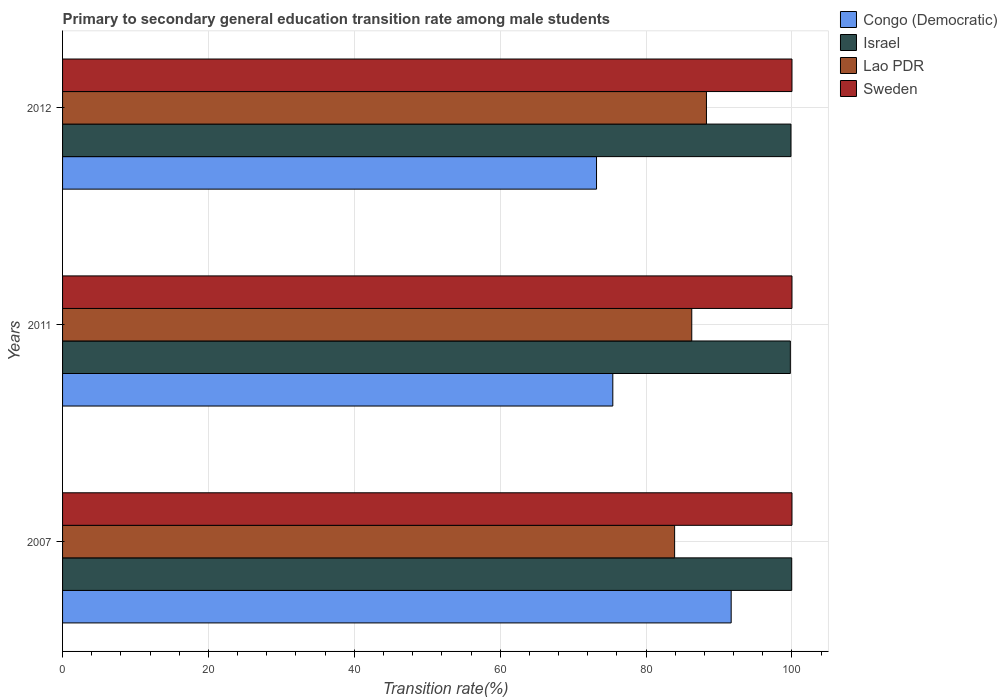How many different coloured bars are there?
Keep it short and to the point. 4. How many groups of bars are there?
Offer a very short reply. 3. Are the number of bars per tick equal to the number of legend labels?
Your response must be concise. Yes. Are the number of bars on each tick of the Y-axis equal?
Give a very brief answer. Yes. What is the label of the 1st group of bars from the top?
Your answer should be very brief. 2012. What is the transition rate in Lao PDR in 2012?
Your answer should be very brief. 88.27. Across all years, what is the maximum transition rate in Israel?
Keep it short and to the point. 99.96. Across all years, what is the minimum transition rate in Sweden?
Your answer should be very brief. 100. In which year was the transition rate in Israel maximum?
Give a very brief answer. 2007. What is the total transition rate in Lao PDR in the graph?
Make the answer very short. 258.44. What is the difference between the transition rate in Israel in 2007 and that in 2011?
Your answer should be compact. 0.19. What is the difference between the transition rate in Israel in 2011 and the transition rate in Congo (Democratic) in 2012?
Your answer should be very brief. 26.57. What is the average transition rate in Lao PDR per year?
Make the answer very short. 86.15. In the year 2007, what is the difference between the transition rate in Lao PDR and transition rate in Sweden?
Offer a terse response. -16.09. What is the ratio of the transition rate in Congo (Democratic) in 2007 to that in 2011?
Provide a succinct answer. 1.22. Is the transition rate in Lao PDR in 2007 less than that in 2012?
Your answer should be compact. Yes. Is the difference between the transition rate in Lao PDR in 2007 and 2011 greater than the difference between the transition rate in Sweden in 2007 and 2011?
Make the answer very short. No. What is the difference between the highest and the second highest transition rate in Israel?
Your answer should be very brief. 0.1. What is the difference between the highest and the lowest transition rate in Israel?
Offer a terse response. 0.19. In how many years, is the transition rate in Israel greater than the average transition rate in Israel taken over all years?
Your response must be concise. 1. Is the sum of the transition rate in Sweden in 2007 and 2012 greater than the maximum transition rate in Congo (Democratic) across all years?
Offer a terse response. Yes. What does the 1st bar from the bottom in 2011 represents?
Offer a terse response. Congo (Democratic). How many bars are there?
Offer a terse response. 12. Are all the bars in the graph horizontal?
Ensure brevity in your answer.  Yes. What is the difference between two consecutive major ticks on the X-axis?
Your answer should be compact. 20. How many legend labels are there?
Your answer should be very brief. 4. What is the title of the graph?
Offer a terse response. Primary to secondary general education transition rate among male students. What is the label or title of the X-axis?
Give a very brief answer. Transition rate(%). What is the label or title of the Y-axis?
Offer a very short reply. Years. What is the Transition rate(%) in Congo (Democratic) in 2007?
Your answer should be compact. 91.66. What is the Transition rate(%) of Israel in 2007?
Provide a succinct answer. 99.96. What is the Transition rate(%) in Lao PDR in 2007?
Offer a terse response. 83.91. What is the Transition rate(%) of Sweden in 2007?
Ensure brevity in your answer.  100. What is the Transition rate(%) of Congo (Democratic) in 2011?
Provide a short and direct response. 75.44. What is the Transition rate(%) of Israel in 2011?
Make the answer very short. 99.78. What is the Transition rate(%) of Lao PDR in 2011?
Your answer should be very brief. 86.26. What is the Transition rate(%) of Sweden in 2011?
Provide a short and direct response. 100. What is the Transition rate(%) of Congo (Democratic) in 2012?
Keep it short and to the point. 73.2. What is the Transition rate(%) in Israel in 2012?
Your answer should be compact. 99.86. What is the Transition rate(%) of Lao PDR in 2012?
Ensure brevity in your answer.  88.27. What is the Transition rate(%) in Sweden in 2012?
Keep it short and to the point. 100. Across all years, what is the maximum Transition rate(%) of Congo (Democratic)?
Your answer should be compact. 91.66. Across all years, what is the maximum Transition rate(%) in Israel?
Offer a terse response. 99.96. Across all years, what is the maximum Transition rate(%) in Lao PDR?
Your response must be concise. 88.27. Across all years, what is the minimum Transition rate(%) of Congo (Democratic)?
Make the answer very short. 73.2. Across all years, what is the minimum Transition rate(%) of Israel?
Ensure brevity in your answer.  99.78. Across all years, what is the minimum Transition rate(%) in Lao PDR?
Keep it short and to the point. 83.91. Across all years, what is the minimum Transition rate(%) in Sweden?
Keep it short and to the point. 100. What is the total Transition rate(%) of Congo (Democratic) in the graph?
Your response must be concise. 240.3. What is the total Transition rate(%) in Israel in the graph?
Ensure brevity in your answer.  299.6. What is the total Transition rate(%) in Lao PDR in the graph?
Your response must be concise. 258.44. What is the total Transition rate(%) in Sweden in the graph?
Your response must be concise. 300. What is the difference between the Transition rate(%) in Congo (Democratic) in 2007 and that in 2011?
Your answer should be compact. 16.23. What is the difference between the Transition rate(%) in Israel in 2007 and that in 2011?
Your response must be concise. 0.19. What is the difference between the Transition rate(%) of Lao PDR in 2007 and that in 2011?
Make the answer very short. -2.35. What is the difference between the Transition rate(%) of Sweden in 2007 and that in 2011?
Your answer should be very brief. 0. What is the difference between the Transition rate(%) in Congo (Democratic) in 2007 and that in 2012?
Keep it short and to the point. 18.46. What is the difference between the Transition rate(%) in Israel in 2007 and that in 2012?
Provide a short and direct response. 0.1. What is the difference between the Transition rate(%) of Lao PDR in 2007 and that in 2012?
Your answer should be compact. -4.36. What is the difference between the Transition rate(%) in Sweden in 2007 and that in 2012?
Your answer should be compact. 0. What is the difference between the Transition rate(%) in Congo (Democratic) in 2011 and that in 2012?
Offer a terse response. 2.23. What is the difference between the Transition rate(%) in Israel in 2011 and that in 2012?
Your answer should be very brief. -0.09. What is the difference between the Transition rate(%) in Lao PDR in 2011 and that in 2012?
Your answer should be very brief. -2.01. What is the difference between the Transition rate(%) of Congo (Democratic) in 2007 and the Transition rate(%) of Israel in 2011?
Provide a succinct answer. -8.11. What is the difference between the Transition rate(%) of Congo (Democratic) in 2007 and the Transition rate(%) of Lao PDR in 2011?
Provide a short and direct response. 5.4. What is the difference between the Transition rate(%) in Congo (Democratic) in 2007 and the Transition rate(%) in Sweden in 2011?
Your response must be concise. -8.34. What is the difference between the Transition rate(%) of Israel in 2007 and the Transition rate(%) of Lao PDR in 2011?
Your response must be concise. 13.7. What is the difference between the Transition rate(%) in Israel in 2007 and the Transition rate(%) in Sweden in 2011?
Ensure brevity in your answer.  -0.04. What is the difference between the Transition rate(%) in Lao PDR in 2007 and the Transition rate(%) in Sweden in 2011?
Your answer should be very brief. -16.09. What is the difference between the Transition rate(%) in Congo (Democratic) in 2007 and the Transition rate(%) in Israel in 2012?
Provide a succinct answer. -8.2. What is the difference between the Transition rate(%) of Congo (Democratic) in 2007 and the Transition rate(%) of Lao PDR in 2012?
Offer a terse response. 3.39. What is the difference between the Transition rate(%) of Congo (Democratic) in 2007 and the Transition rate(%) of Sweden in 2012?
Your answer should be compact. -8.34. What is the difference between the Transition rate(%) in Israel in 2007 and the Transition rate(%) in Lao PDR in 2012?
Your answer should be compact. 11.69. What is the difference between the Transition rate(%) of Israel in 2007 and the Transition rate(%) of Sweden in 2012?
Offer a very short reply. -0.04. What is the difference between the Transition rate(%) of Lao PDR in 2007 and the Transition rate(%) of Sweden in 2012?
Ensure brevity in your answer.  -16.09. What is the difference between the Transition rate(%) in Congo (Democratic) in 2011 and the Transition rate(%) in Israel in 2012?
Your response must be concise. -24.42. What is the difference between the Transition rate(%) of Congo (Democratic) in 2011 and the Transition rate(%) of Lao PDR in 2012?
Your response must be concise. -12.84. What is the difference between the Transition rate(%) in Congo (Democratic) in 2011 and the Transition rate(%) in Sweden in 2012?
Your answer should be very brief. -24.56. What is the difference between the Transition rate(%) of Israel in 2011 and the Transition rate(%) of Lao PDR in 2012?
Your answer should be very brief. 11.5. What is the difference between the Transition rate(%) of Israel in 2011 and the Transition rate(%) of Sweden in 2012?
Provide a short and direct response. -0.22. What is the difference between the Transition rate(%) in Lao PDR in 2011 and the Transition rate(%) in Sweden in 2012?
Provide a short and direct response. -13.74. What is the average Transition rate(%) of Congo (Democratic) per year?
Give a very brief answer. 80.1. What is the average Transition rate(%) of Israel per year?
Ensure brevity in your answer.  99.87. What is the average Transition rate(%) of Lao PDR per year?
Offer a very short reply. 86.15. In the year 2007, what is the difference between the Transition rate(%) of Congo (Democratic) and Transition rate(%) of Israel?
Your answer should be compact. -8.3. In the year 2007, what is the difference between the Transition rate(%) of Congo (Democratic) and Transition rate(%) of Lao PDR?
Provide a succinct answer. 7.75. In the year 2007, what is the difference between the Transition rate(%) in Congo (Democratic) and Transition rate(%) in Sweden?
Offer a very short reply. -8.34. In the year 2007, what is the difference between the Transition rate(%) of Israel and Transition rate(%) of Lao PDR?
Provide a succinct answer. 16.05. In the year 2007, what is the difference between the Transition rate(%) in Israel and Transition rate(%) in Sweden?
Keep it short and to the point. -0.04. In the year 2007, what is the difference between the Transition rate(%) in Lao PDR and Transition rate(%) in Sweden?
Provide a short and direct response. -16.09. In the year 2011, what is the difference between the Transition rate(%) in Congo (Democratic) and Transition rate(%) in Israel?
Your answer should be compact. -24.34. In the year 2011, what is the difference between the Transition rate(%) of Congo (Democratic) and Transition rate(%) of Lao PDR?
Provide a succinct answer. -10.82. In the year 2011, what is the difference between the Transition rate(%) of Congo (Democratic) and Transition rate(%) of Sweden?
Offer a very short reply. -24.56. In the year 2011, what is the difference between the Transition rate(%) of Israel and Transition rate(%) of Lao PDR?
Keep it short and to the point. 13.52. In the year 2011, what is the difference between the Transition rate(%) in Israel and Transition rate(%) in Sweden?
Your answer should be very brief. -0.22. In the year 2011, what is the difference between the Transition rate(%) in Lao PDR and Transition rate(%) in Sweden?
Make the answer very short. -13.74. In the year 2012, what is the difference between the Transition rate(%) of Congo (Democratic) and Transition rate(%) of Israel?
Keep it short and to the point. -26.66. In the year 2012, what is the difference between the Transition rate(%) in Congo (Democratic) and Transition rate(%) in Lao PDR?
Ensure brevity in your answer.  -15.07. In the year 2012, what is the difference between the Transition rate(%) in Congo (Democratic) and Transition rate(%) in Sweden?
Offer a terse response. -26.8. In the year 2012, what is the difference between the Transition rate(%) of Israel and Transition rate(%) of Lao PDR?
Give a very brief answer. 11.59. In the year 2012, what is the difference between the Transition rate(%) in Israel and Transition rate(%) in Sweden?
Your response must be concise. -0.14. In the year 2012, what is the difference between the Transition rate(%) in Lao PDR and Transition rate(%) in Sweden?
Keep it short and to the point. -11.73. What is the ratio of the Transition rate(%) of Congo (Democratic) in 2007 to that in 2011?
Provide a succinct answer. 1.22. What is the ratio of the Transition rate(%) of Israel in 2007 to that in 2011?
Offer a terse response. 1. What is the ratio of the Transition rate(%) of Lao PDR in 2007 to that in 2011?
Your answer should be compact. 0.97. What is the ratio of the Transition rate(%) in Sweden in 2007 to that in 2011?
Your answer should be compact. 1. What is the ratio of the Transition rate(%) of Congo (Democratic) in 2007 to that in 2012?
Give a very brief answer. 1.25. What is the ratio of the Transition rate(%) of Lao PDR in 2007 to that in 2012?
Your answer should be compact. 0.95. What is the ratio of the Transition rate(%) of Congo (Democratic) in 2011 to that in 2012?
Keep it short and to the point. 1.03. What is the ratio of the Transition rate(%) in Israel in 2011 to that in 2012?
Provide a succinct answer. 1. What is the ratio of the Transition rate(%) of Lao PDR in 2011 to that in 2012?
Provide a succinct answer. 0.98. What is the ratio of the Transition rate(%) of Sweden in 2011 to that in 2012?
Provide a short and direct response. 1. What is the difference between the highest and the second highest Transition rate(%) of Congo (Democratic)?
Provide a succinct answer. 16.23. What is the difference between the highest and the second highest Transition rate(%) in Israel?
Ensure brevity in your answer.  0.1. What is the difference between the highest and the second highest Transition rate(%) of Lao PDR?
Ensure brevity in your answer.  2.01. What is the difference between the highest and the second highest Transition rate(%) of Sweden?
Your answer should be very brief. 0. What is the difference between the highest and the lowest Transition rate(%) of Congo (Democratic)?
Your answer should be compact. 18.46. What is the difference between the highest and the lowest Transition rate(%) in Israel?
Your answer should be very brief. 0.19. What is the difference between the highest and the lowest Transition rate(%) in Lao PDR?
Your answer should be compact. 4.36. What is the difference between the highest and the lowest Transition rate(%) in Sweden?
Offer a very short reply. 0. 